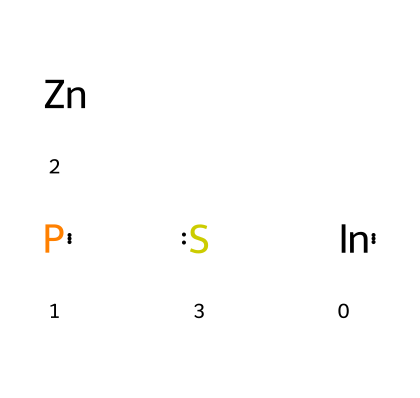What is the core material of the quantum dot? The core of the quantum dot as represented by the chemical is Indium Phosphide (InP). This is determined by the presence of In and P in the SMILES notation, which indicates the core composition.
Answer: Indium Phosphide What is the shell material of the quantum dot? The shell material in the given structure is Zinc Sulfide (ZnS). This is inferred from the presence of Zn and S in the SMILES notation, which suggest the outer shell of the quantum dot.
Answer: Zinc Sulfide How many different elements are present in the structure? The structure contains four distinct elements: Indium, Phosphorus, Zinc, and Sulfur. By counting the unique elements represented in the SMILES notation, we arrive at this total.
Answer: four What type of nanoparticles are represented by this chemical structure? The chemical structure represents quantum dots, which are semiconductor nanoparticles used in various applications including biomedical imaging, indicated by their composition and size.
Answer: quantum dots Why is the core-shell structure advantageous for biomedicine? The core-shell structure improves stability and photoluminescence properties, enhancing the effectiveness of quantum dots in imaging applications. This is based on the understanding that the shell protects the core and can improve optical properties, making it relevant in biomedical contexts.
Answer: stability and photoluminescence What is the role of the shell in the quantum dot? The shell serves to passivate the core, reducing surface defects, and improving photophysical properties, which are crucial for applications in imaging. The reasoning here hinges on the fundamental purpose of a shell in quantum dots, which typically aims to enhance their performance.
Answer: passivation 